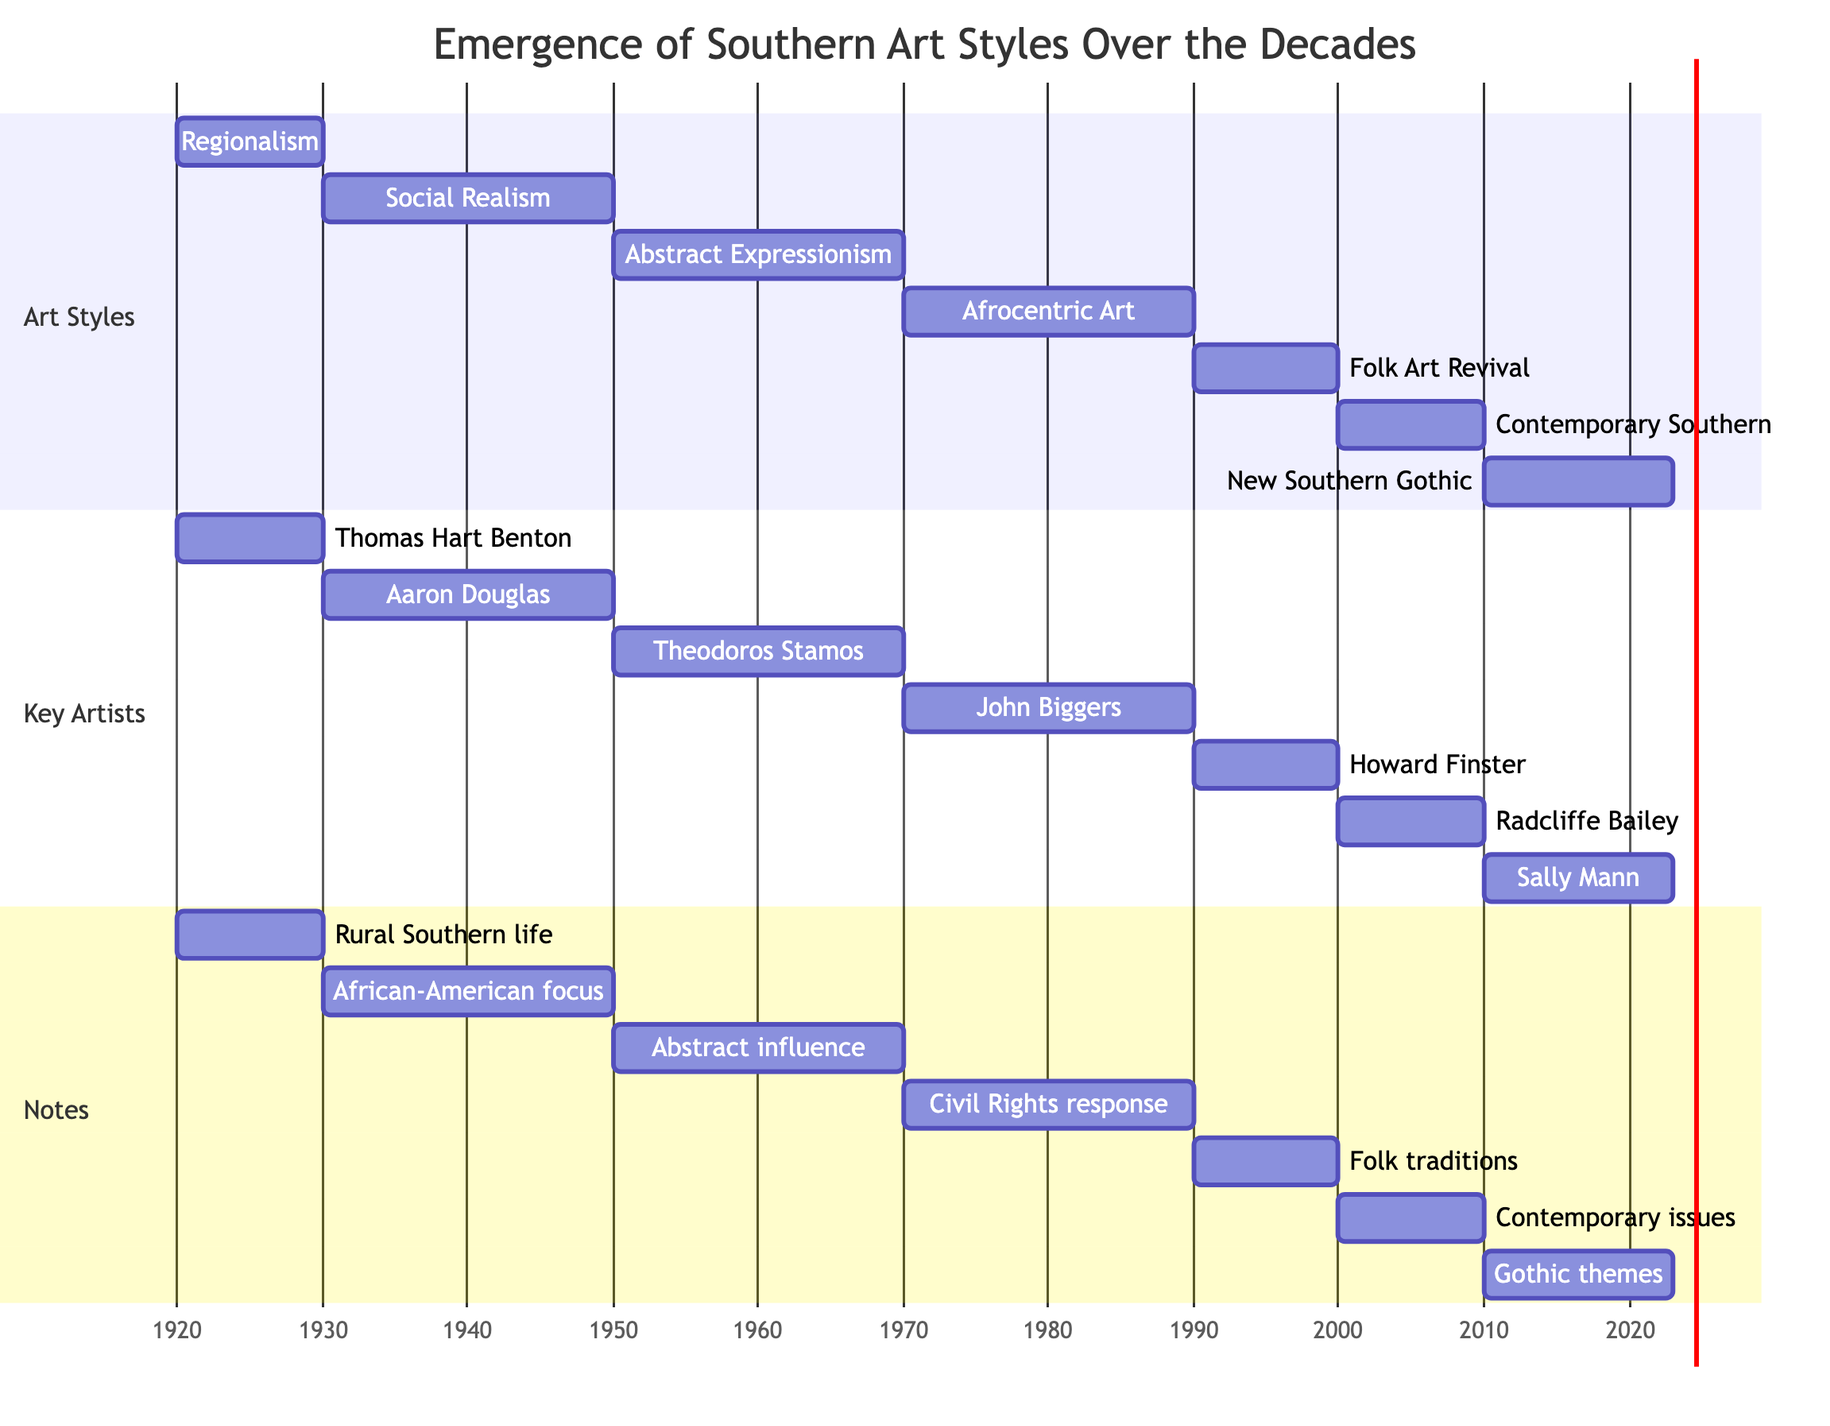What art style is associated with the 1930s-1940s? The diagram shows a section labeled "Art Styles," where the 1930s-1940s is associated with "Social Realism." This can be found by locating the corresponding time range in the Gantt chart and observing the label next to it.
Answer: Social Realism Who are the key artists for the 1970s-1980s art style? By looking in the "Key Artists" section, the artists listed alongside the art style "Afrocentric Art" in the 1970s-1980s time range are identified. The names are noted below the art style, leading to the conclusion.
Answer: John Biggers, Emma Amos How many distinct styles are shown in the chart? Counting the unique styles listed in the "Art Styles" section of the Gantt chart, each interval of time corresponds to a different style, leading to a total count of the different art movements represented.
Answer: 7 Which artist represents the New Southern Gothic style? In the Gantt chart, under the "Key Artists" section, the label for the New Southern Gothic corresponds to the artist mentioned there. By tracking down the period and linking it to the artists listed, the answer can be determined.
Answer: Sally Mann, Kehinde Wiley In which decade did Folk Art Revival emerge? The Gantt chart indicates the Folk Art Revival period begins in the 1990s, which is explicitly labeled in the "Art Styles" section, providing a straightforward timeline reference.
Answer: 1990s What is the primary focus of Social Realism? Looking in the "Notes" section for the Social Realism period, it specifies an emphasis on social issues and African-American life in the South, summarizing the key focus of that style.
Answer: African-American life Which art movement spans the longest duration in the chart? By evaluating the duration for each style from the Gantt chart, it can be seen that Social Realism covers 20 years, which is longer than any other segment shown, leading to this conclusion.
Answer: Social Realism What was a notable influence on Southern artists during the 1950s-1960s? In the "Notes" section corresponding to Abstract Expressionism, it mentions that although the style did not originate in the South, it influenced local artists towards abstraction, which is what the question seeks.
Answer: Abstract influence How many key artists are linked to the period of Contemporary Southern Art? The "Key Artists" section specifically under the Contemporary Southern Art period lists two artists alongside it; thus, counting them provides the answer directly from the chart.
Answer: 2 